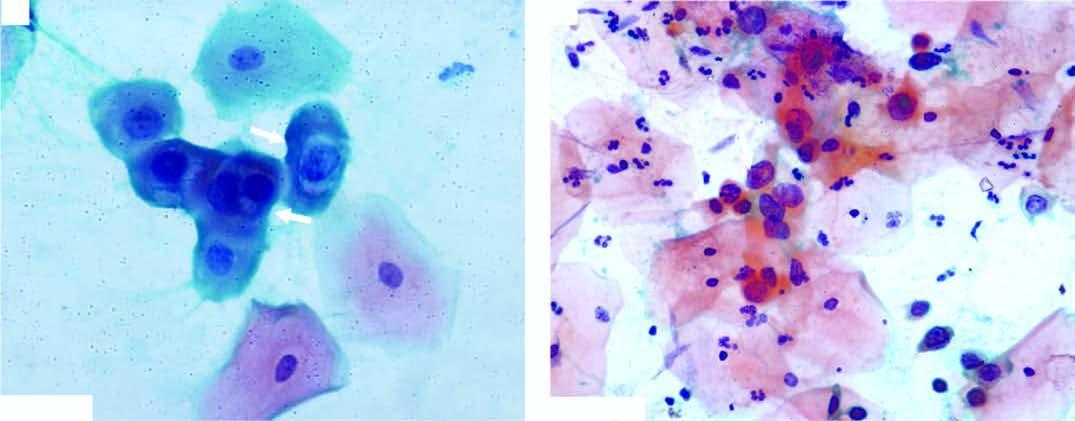did suspension of leucocytes above have irregular nuclear outlines?
Answer the question using a single word or phrase. No 